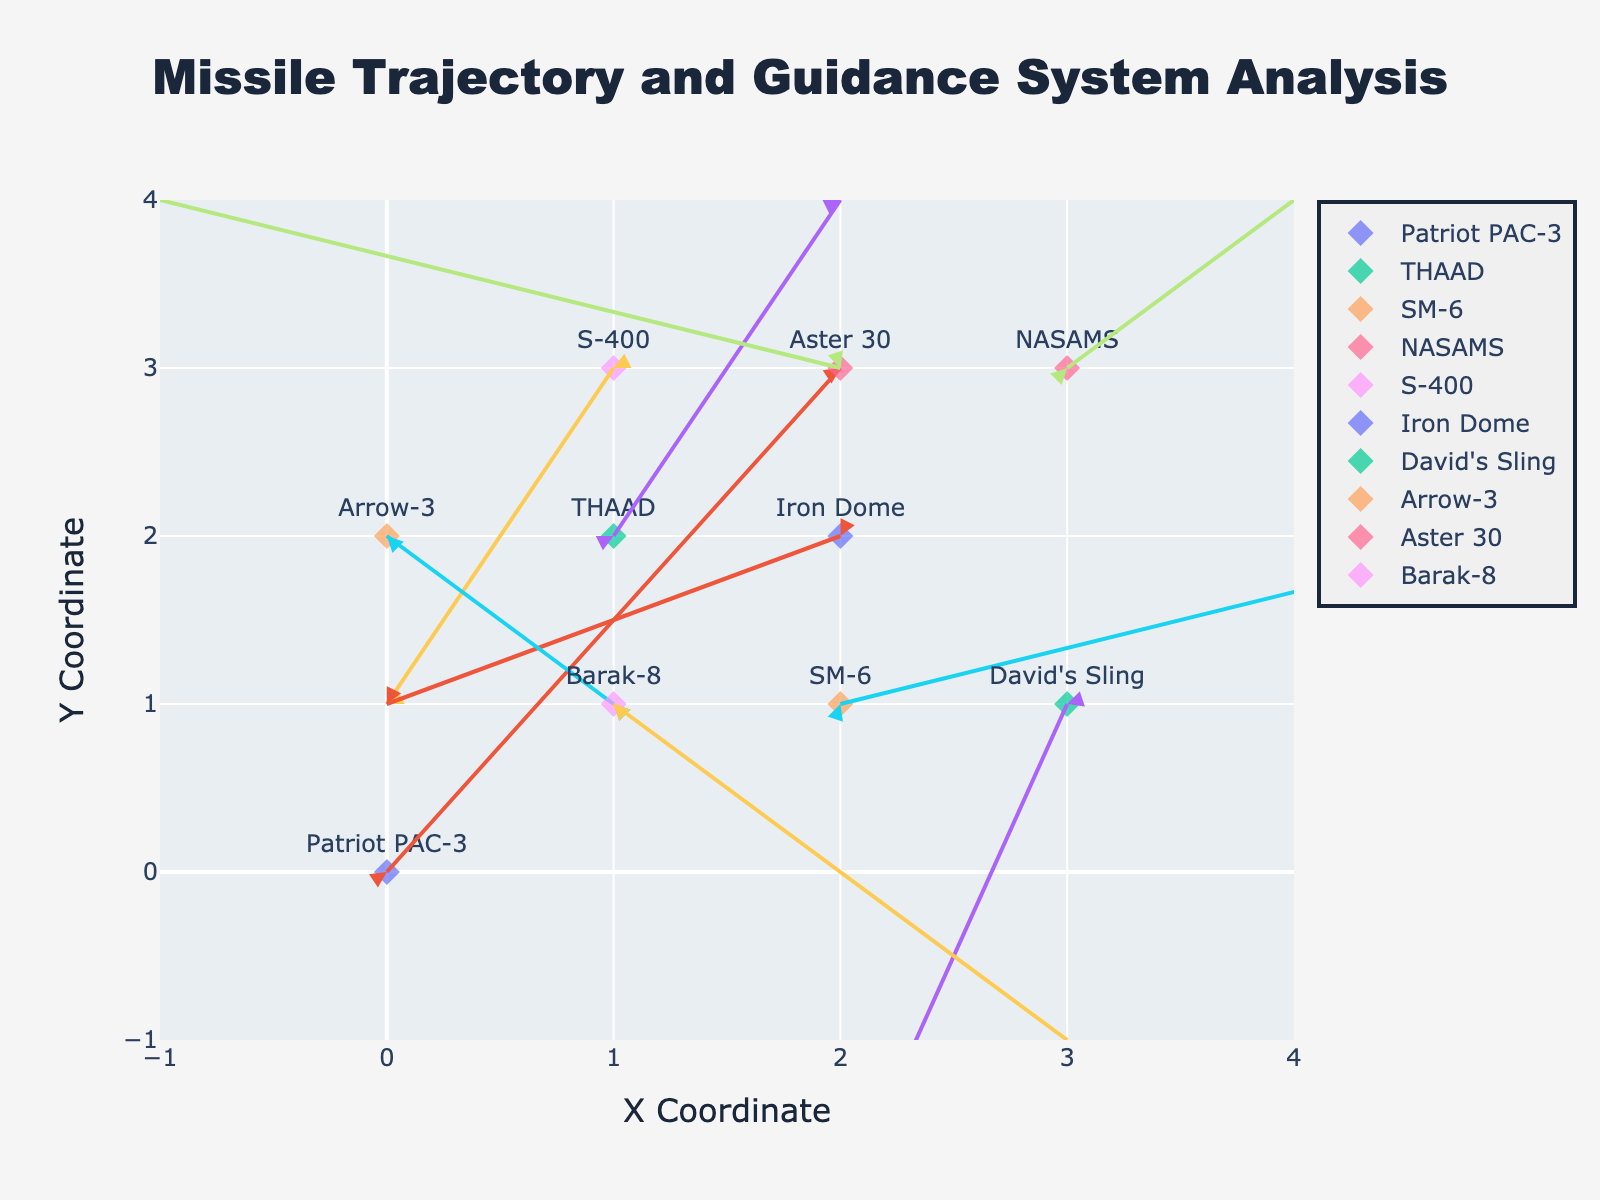What's the title of the figure? The title is usually displayed prominently at the top of the figure. In this case, it is "Missile Trajectory and Guidance System Analysis".
Answer: Missile Trajectory and Guidance System Analysis What are the ranges of the X and Y axes? The X and Y axes ranges are indicated by the values on their respective scales. Here, the X axis ranges from -1 to 4, and the Y axis ranges from -1 to 4.
Answer: -1 to 4 (both axes) How many different missile types are displayed on the quiver plot? The legend indicates different missile types. Observing the legend, there are 10 different missile types.
Answer: 10 Which missile type is located at coordinates (3, 3)? To determine the missile type at specific coordinates, look where the point at (3, 3) is labeled. It is the "NASAMS" missile.
Answer: NASAMS Which missile has the longest trajectory vector? By comparing the lengths of the vectors (u,v) visually or by computing the magnitude (sqrt(u^2 + v^2)), "SM-6" has the largest trajectory vector of (3, 1) with a magnitude of sqrt(3^2 + 1^2) = sqrt(10) ≈ 3.16.
Answer: SM-6 What is the total vector displacement for the Iron Dome missile? Total vector displacement can be calculated by summing up its u and v components: u = -2, v = -1. Total displacement = sqrt((-2)^2 + (-1)^2) = sqrt(5).
Answer: sqrt(5) Which missile type shows a downward trajectory based on its vector components? To determine downward trajectory, look for negative values in the v component. Missiles with negative v components are "S-400", "Iron Dome", "David's Sling", "Arrow-3", and "Barak-8".
Answer: S-400, Iron Dome, David's Sling, Arrow-3, Barak-8 What are the coordinates and vector components of the Patriot PAC-3 missile? Coordinates and vectors are read directly from the figure. For Patriot PAC-3, it is located at (0, 0) with vector (u, v) = (2, 3).
Answer: Coordinates: (0, 0), Vector: (2, 3) Compare the vector components of Arrow-3 and Aster 30, which one has the larger magnitude? Calculate the magnitudes of each vector: Arrow-3 (u = 1, v = -1) -> magnitude = sqrt(1^2 + (-1)^2) = sqrt(2); Aster 30 (u = -3, v = 1) -> magnitude = sqrt((-3)^2 + 1^2) = sqrt(10). Aster 30 has the larger magnitude.
Answer: Aster 30 